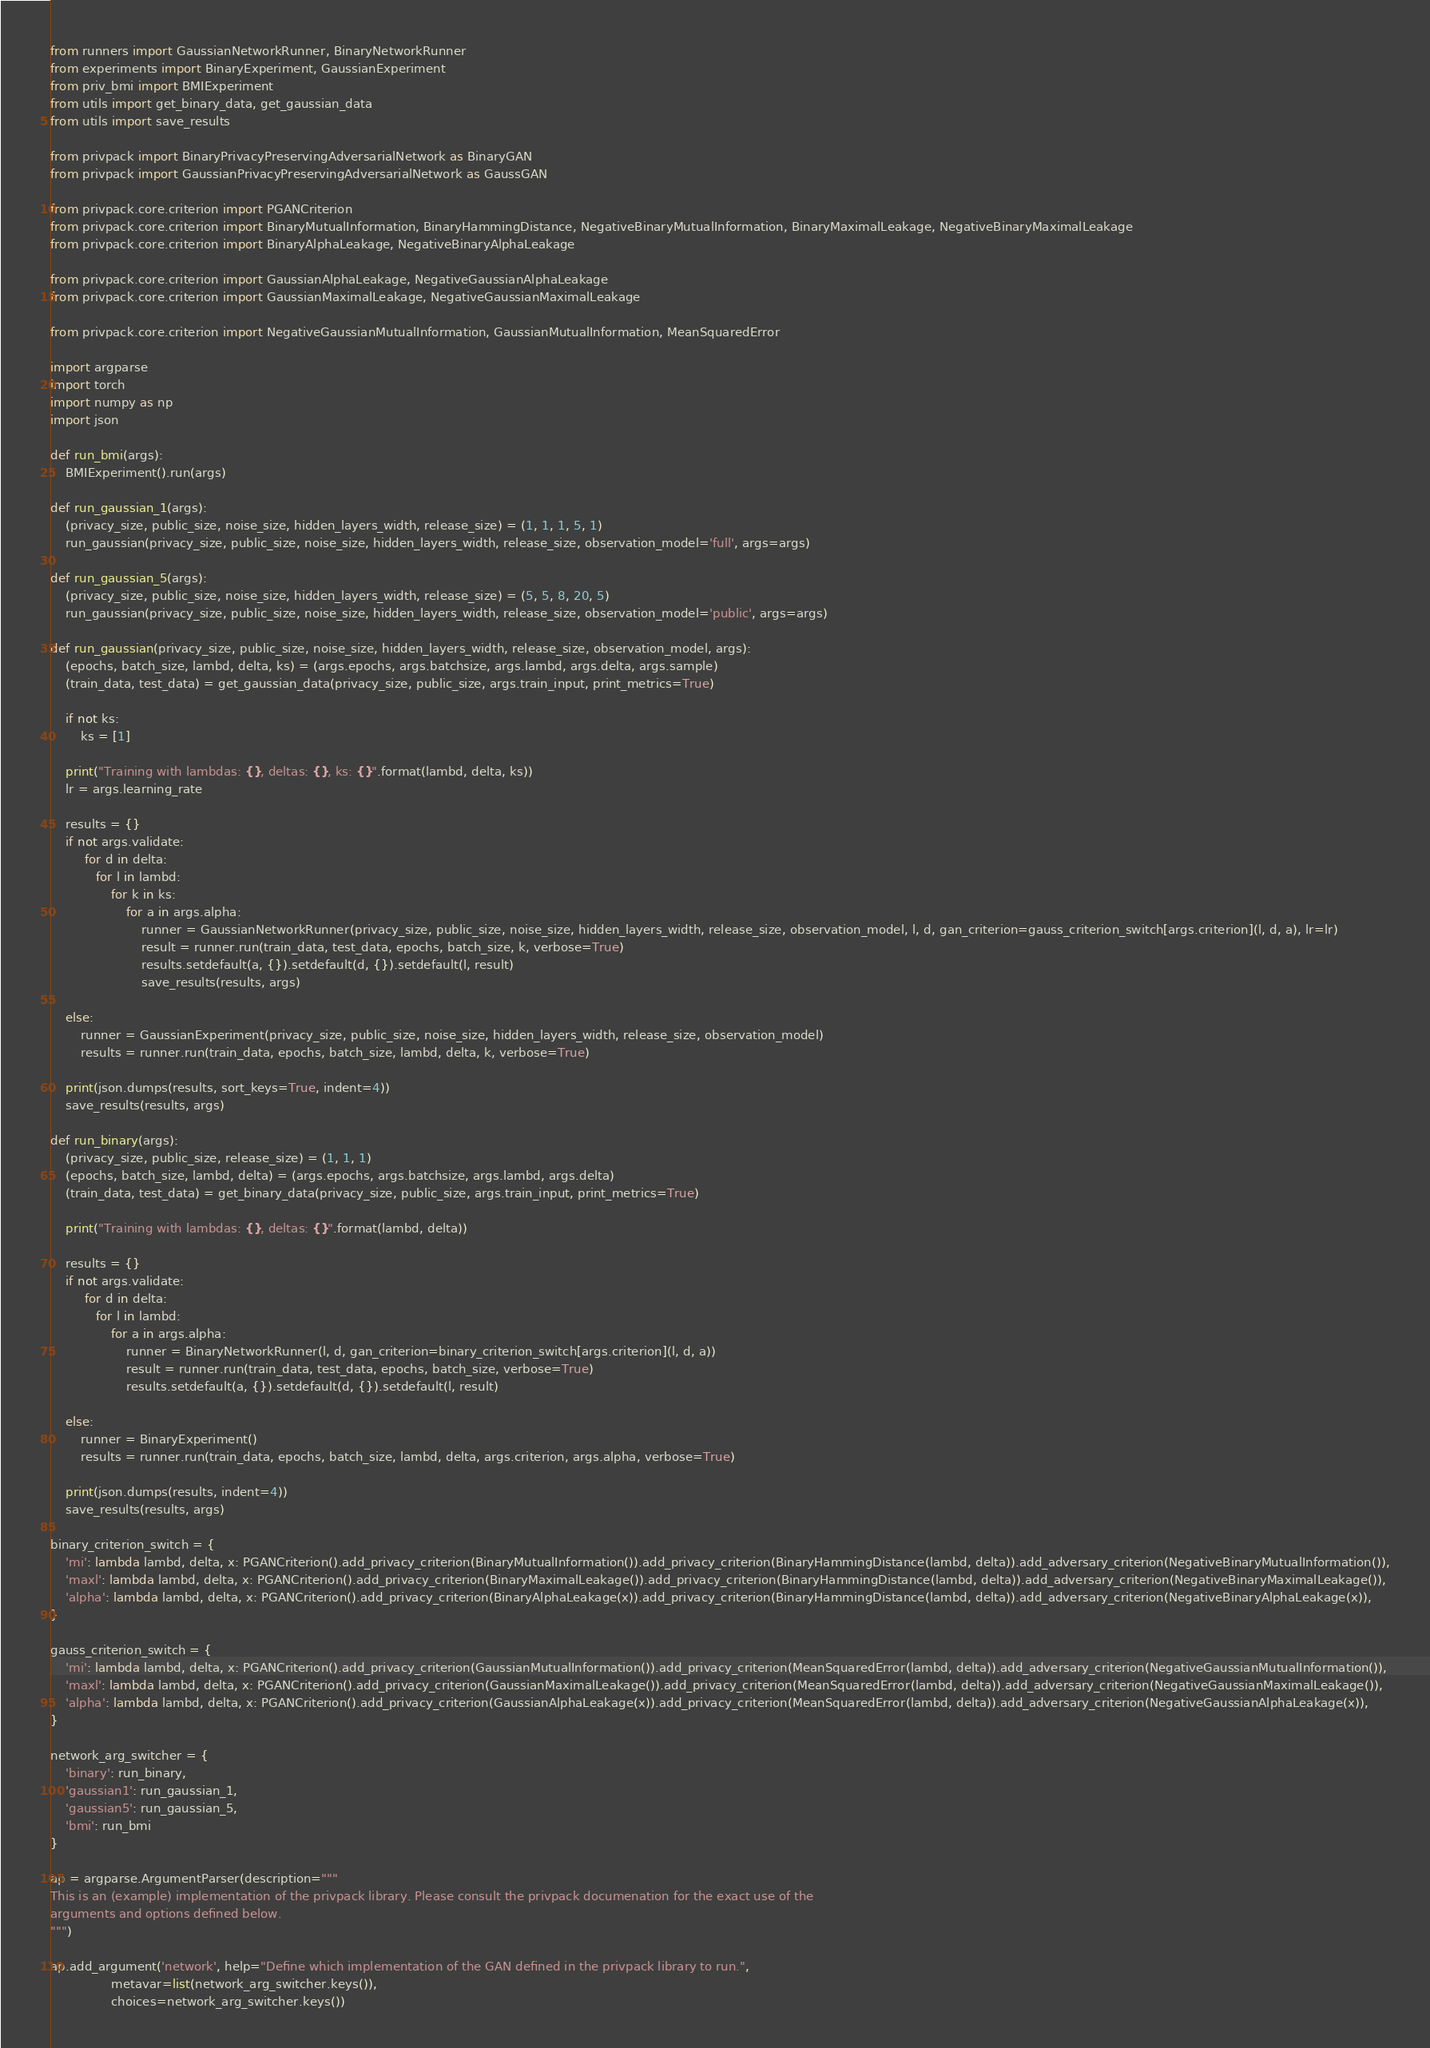<code> <loc_0><loc_0><loc_500><loc_500><_Python_>from runners import GaussianNetworkRunner, BinaryNetworkRunner
from experiments import BinaryExperiment, GaussianExperiment
from priv_bmi import BMIExperiment
from utils import get_binary_data, get_gaussian_data
from utils import save_results

from privpack import BinaryPrivacyPreservingAdversarialNetwork as BinaryGAN
from privpack import GaussianPrivacyPreservingAdversarialNetwork as GaussGAN

from privpack.core.criterion import PGANCriterion
from privpack.core.criterion import BinaryMutualInformation, BinaryHammingDistance, NegativeBinaryMutualInformation, BinaryMaximalLeakage, NegativeBinaryMaximalLeakage
from privpack.core.criterion import BinaryAlphaLeakage, NegativeBinaryAlphaLeakage

from privpack.core.criterion import GaussianAlphaLeakage, NegativeGaussianAlphaLeakage
from privpack.core.criterion import GaussianMaximalLeakage, NegativeGaussianMaximalLeakage

from privpack.core.criterion import NegativeGaussianMutualInformation, GaussianMutualInformation, MeanSquaredError

import argparse
import torch
import numpy as np
import json

def run_bmi(args):
    BMIExperiment().run(args)

def run_gaussian_1(args):
    (privacy_size, public_size, noise_size, hidden_layers_width, release_size) = (1, 1, 1, 5, 1)
    run_gaussian(privacy_size, public_size, noise_size, hidden_layers_width, release_size, observation_model='full', args=args)

def run_gaussian_5(args):
    (privacy_size, public_size, noise_size, hidden_layers_width, release_size) = (5, 5, 8, 20, 5)
    run_gaussian(privacy_size, public_size, noise_size, hidden_layers_width, release_size, observation_model='public', args=args)

def run_gaussian(privacy_size, public_size, noise_size, hidden_layers_width, release_size, observation_model, args):
    (epochs, batch_size, lambd, delta, ks) = (args.epochs, args.batchsize, args.lambd, args.delta, args.sample)
    (train_data, test_data) = get_gaussian_data(privacy_size, public_size, args.train_input, print_metrics=True)

    if not ks:
        ks = [1]

    print("Training with lambdas: {}, deltas: {}, ks: {}".format(lambd, delta, ks))
    lr = args.learning_rate
    
    results = {}
    if not args.validate:
         for d in delta:
            for l in lambd:
                for k in ks:
                    for a in args.alpha:
                        runner = GaussianNetworkRunner(privacy_size, public_size, noise_size, hidden_layers_width, release_size, observation_model, l, d, gan_criterion=gauss_criterion_switch[args.criterion](l, d, a), lr=lr)
                        result = runner.run(train_data, test_data, epochs, batch_size, k, verbose=True)
                        results.setdefault(a, {}).setdefault(d, {}).setdefault(l, result)
                        save_results(results, args)

    else:
        runner = GaussianExperiment(privacy_size, public_size, noise_size, hidden_layers_width, release_size, observation_model)
        results = runner.run(train_data, epochs, batch_size, lambd, delta, k, verbose=True)

    print(json.dumps(results, sort_keys=True, indent=4))
    save_results(results, args)

def run_binary(args):
    (privacy_size, public_size, release_size) = (1, 1, 1)
    (epochs, batch_size, lambd, delta) = (args.epochs, args.batchsize, args.lambd, args.delta)
    (train_data, test_data) = get_binary_data(privacy_size, public_size, args.train_input, print_metrics=True)

    print("Training with lambdas: {}, deltas: {}".format(lambd, delta))

    results = {}
    if not args.validate:
         for d in delta:
            for l in lambd:
                for a in args.alpha:
                    runner = BinaryNetworkRunner(l, d, gan_criterion=binary_criterion_switch[args.criterion](l, d, a))
                    result = runner.run(train_data, test_data, epochs, batch_size, verbose=True)
                    results.setdefault(a, {}).setdefault(d, {}).setdefault(l, result)

    else:
        runner = BinaryExperiment()
        results = runner.run(train_data, epochs, batch_size, lambd, delta, args.criterion, args.alpha, verbose=True)

    print(json.dumps(results, indent=4))
    save_results(results, args)

binary_criterion_switch = {
    'mi': lambda lambd, delta, x: PGANCriterion().add_privacy_criterion(BinaryMutualInformation()).add_privacy_criterion(BinaryHammingDistance(lambd, delta)).add_adversary_criterion(NegativeBinaryMutualInformation()),
    'maxl': lambda lambd, delta, x: PGANCriterion().add_privacy_criterion(BinaryMaximalLeakage()).add_privacy_criterion(BinaryHammingDistance(lambd, delta)).add_adversary_criterion(NegativeBinaryMaximalLeakage()),
    'alpha': lambda lambd, delta, x: PGANCriterion().add_privacy_criterion(BinaryAlphaLeakage(x)).add_privacy_criterion(BinaryHammingDistance(lambd, delta)).add_adversary_criterion(NegativeBinaryAlphaLeakage(x)),
}

gauss_criterion_switch = {
    'mi': lambda lambd, delta, x: PGANCriterion().add_privacy_criterion(GaussianMutualInformation()).add_privacy_criterion(MeanSquaredError(lambd, delta)).add_adversary_criterion(NegativeGaussianMutualInformation()),
    'maxl': lambda lambd, delta, x: PGANCriterion().add_privacy_criterion(GaussianMaximalLeakage()).add_privacy_criterion(MeanSquaredError(lambd, delta)).add_adversary_criterion(NegativeGaussianMaximalLeakage()),
    'alpha': lambda lambd, delta, x: PGANCriterion().add_privacy_criterion(GaussianAlphaLeakage(x)).add_privacy_criterion(MeanSquaredError(lambd, delta)).add_adversary_criterion(NegativeGaussianAlphaLeakage(x)),
}

network_arg_switcher = {
    'binary': run_binary,
    'gaussian1': run_gaussian_1,
    'gaussian5': run_gaussian_5,
    'bmi': run_bmi
}

ap = argparse.ArgumentParser(description="""
This is an (example) implementation of the privpack library. Please consult the privpack documenation for the exact use of the 
arguments and options defined below.
""")

ap.add_argument('network', help="Define which implementation of the GAN defined in the privpack library to run.", 
                metavar=list(network_arg_switcher.keys()),
                choices=network_arg_switcher.keys())
</code> 